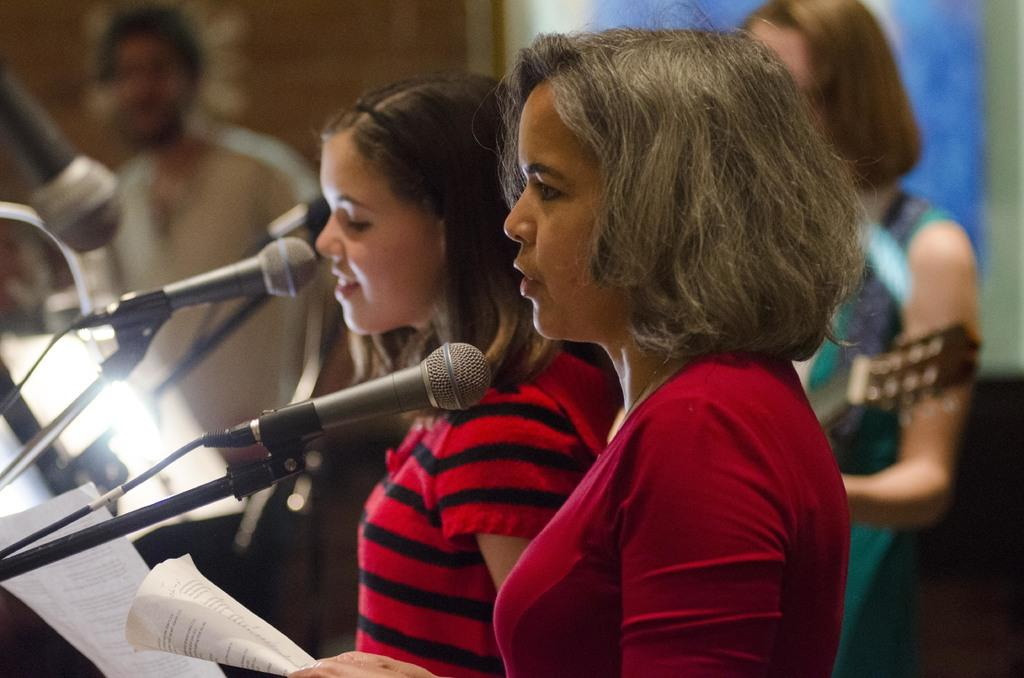What are the two persons in the image holding? The two persons in the image are holding papers. What can be seen behind the two persons holding papers? There are two other persons playing musical instruments in the image. What are the two persons playing musical instruments using? The two persons playing musical instruments are using their respective instruments. What are the two persons holding papers standing in front of? The two persons holding papers are standing in front of a mic. What type of board is being used by the person wearing a skirt in the image? There is no board or person wearing a skirt present in the image. 